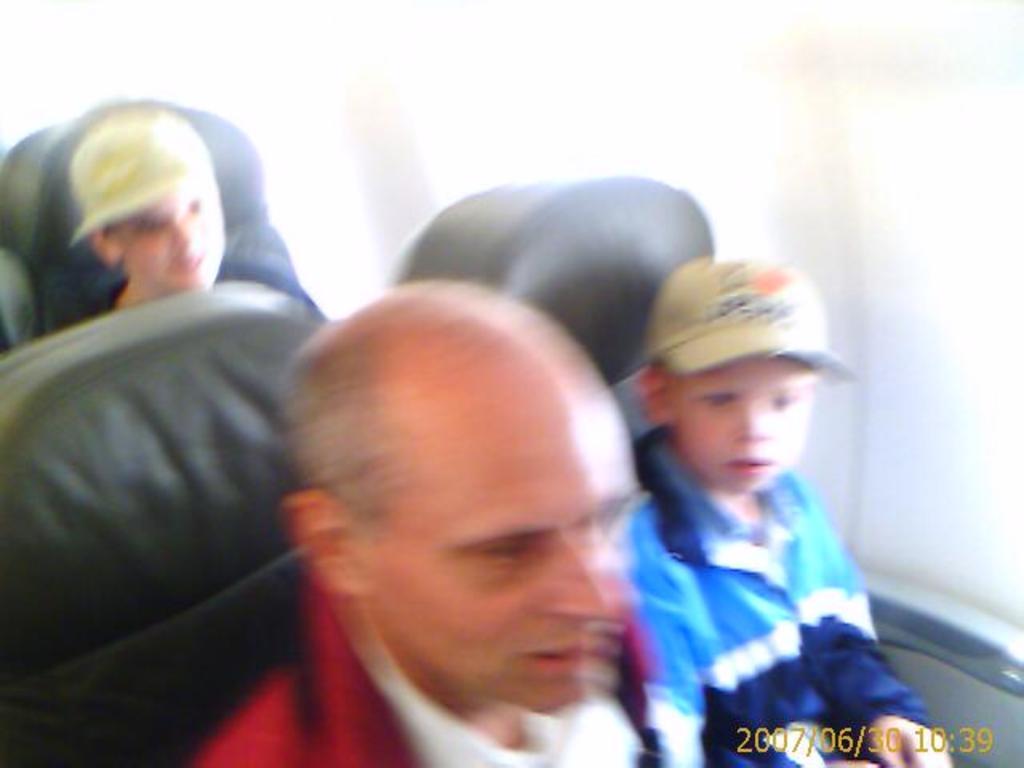Describe this image in one or two sentences. In this picture, we can see and few people sitting on chairs, and we can see the background, date and time on the bottom right side of the picture. 